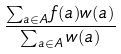<formula> <loc_0><loc_0><loc_500><loc_500>\frac { \sum _ { a \in A } f ( a ) w ( a ) } { \sum _ { a \in A } w ( a ) }</formula> 